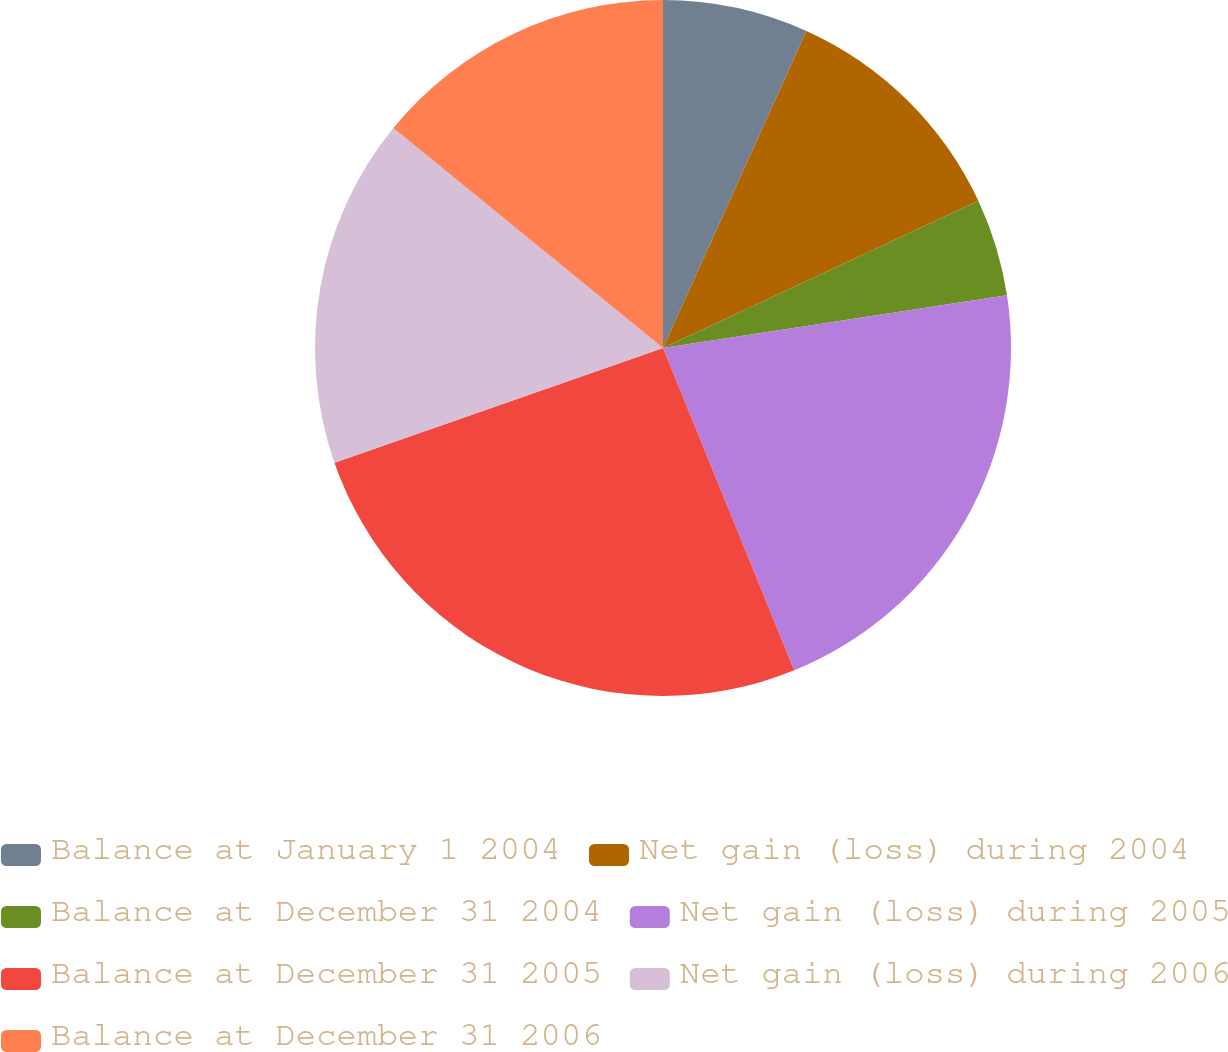Convert chart to OTSL. <chart><loc_0><loc_0><loc_500><loc_500><pie_chart><fcel>Balance at January 1 2004<fcel>Net gain (loss) during 2004<fcel>Balance at December 31 2004<fcel>Net gain (loss) during 2005<fcel>Balance at December 31 2005<fcel>Net gain (loss) during 2006<fcel>Balance at December 31 2006<nl><fcel>6.76%<fcel>11.29%<fcel>4.53%<fcel>21.27%<fcel>25.8%<fcel>16.24%<fcel>14.11%<nl></chart> 